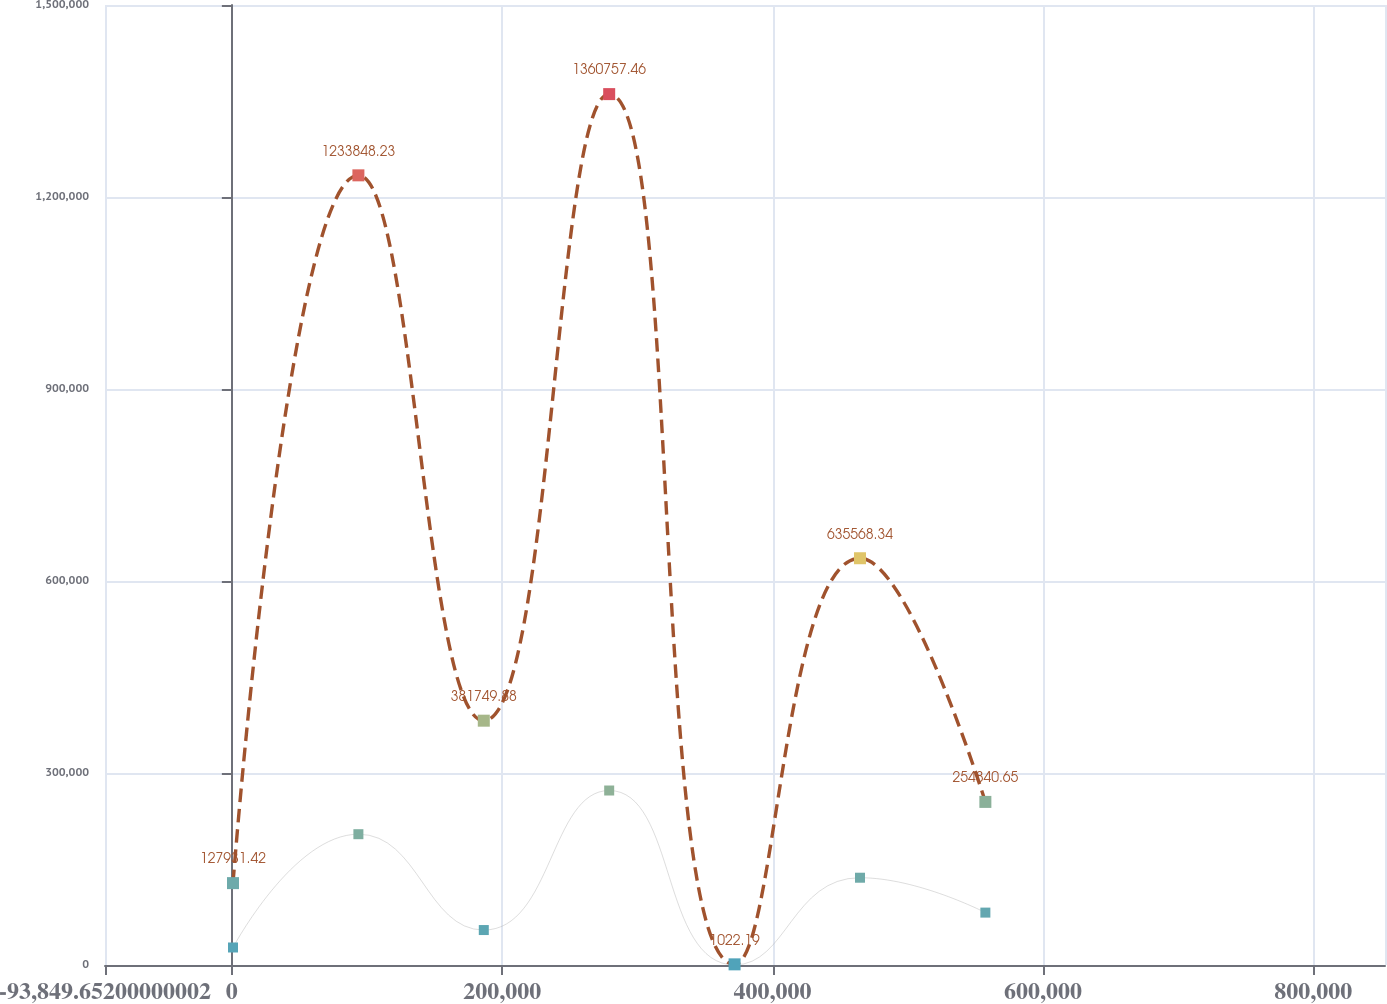Convert chart. <chart><loc_0><loc_0><loc_500><loc_500><line_chart><ecel><fcel>Credit Union<fcel>Total<nl><fcel>839.89<fcel>27361.9<fcel>127931<nl><fcel>93602.6<fcel>204385<fcel>1.23385e+06<nl><fcel>186365<fcel>54615.3<fcel>381750<nl><fcel>279128<fcel>272642<fcel>1.36076e+06<nl><fcel>371891<fcel>108.46<fcel>1022.19<nl><fcel>464653<fcel>136375<fcel>635568<nl><fcel>557416<fcel>81868.7<fcel>254841<nl><fcel>854973<fcel>163629<fcel>762478<nl><fcel>947735<fcel>109122<fcel>508659<nl></chart> 